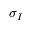Convert formula to latex. <formula><loc_0><loc_0><loc_500><loc_500>\sigma _ { I }</formula> 